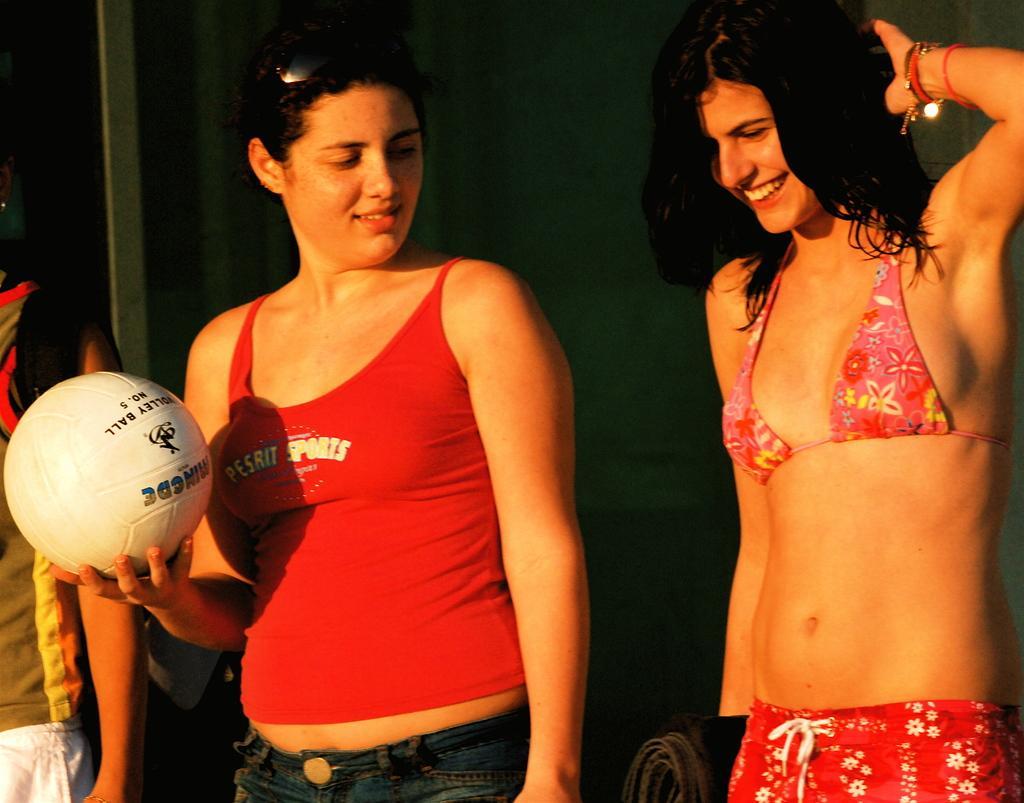Describe this image in one or two sentences. In the right a girl is standing and laughing. On the left a woman is holding a football in her hand. 